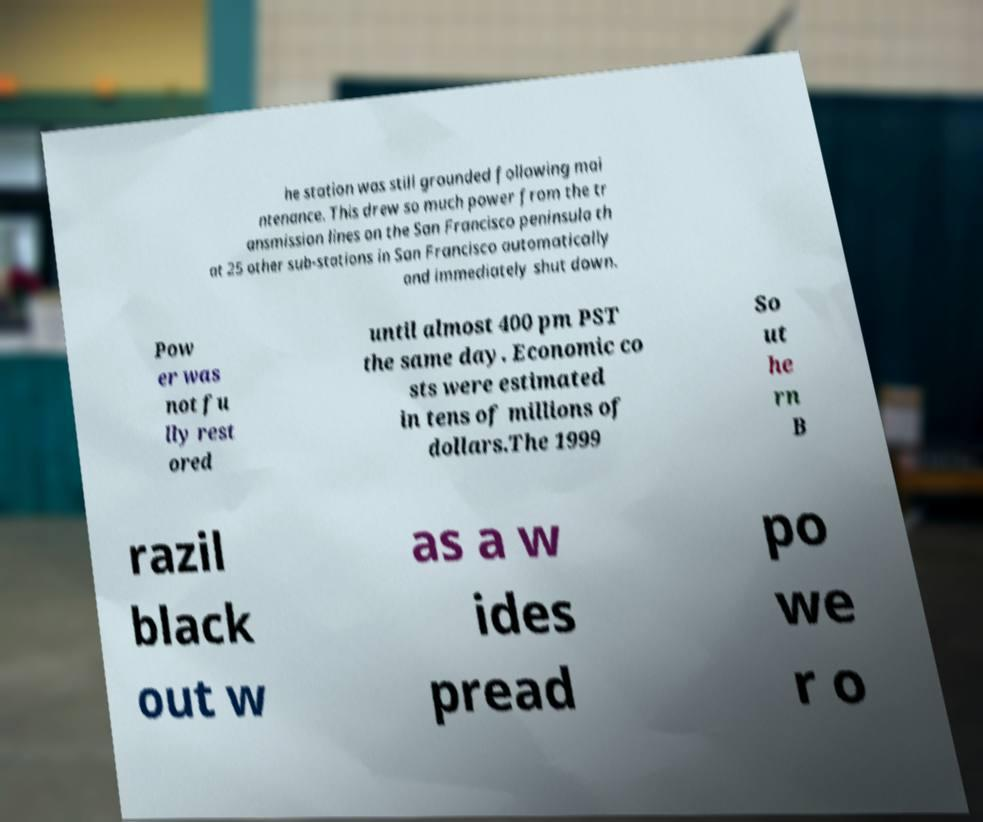Can you read and provide the text displayed in the image?This photo seems to have some interesting text. Can you extract and type it out for me? he station was still grounded following mai ntenance. This drew so much power from the tr ansmission lines on the San Francisco peninsula th at 25 other sub-stations in San Francisco automatically and immediately shut down. Pow er was not fu lly rest ored until almost 400 pm PST the same day. Economic co sts were estimated in tens of millions of dollars.The 1999 So ut he rn B razil black out w as a w ides pread po we r o 